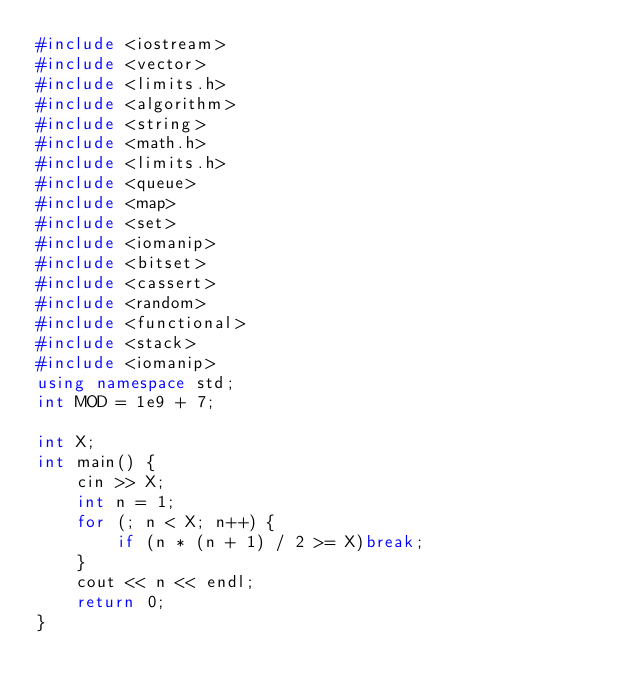Convert code to text. <code><loc_0><loc_0><loc_500><loc_500><_C++_>#include <iostream>
#include <vector>
#include <limits.h>
#include <algorithm>
#include <string>
#include <math.h>
#include <limits.h>
#include <queue>
#include <map>
#include <set>
#include <iomanip>
#include <bitset>
#include <cassert>
#include <random>
#include <functional>
#include <stack>
#include <iomanip>
using namespace std;
int MOD = 1e9 + 7;

int X;
int main() {
	cin >> X;
	int n = 1;
	for (; n < X; n++) {
		if (n * (n + 1) / 2 >= X)break;
	}
	cout << n << endl;
	return 0;
}</code> 